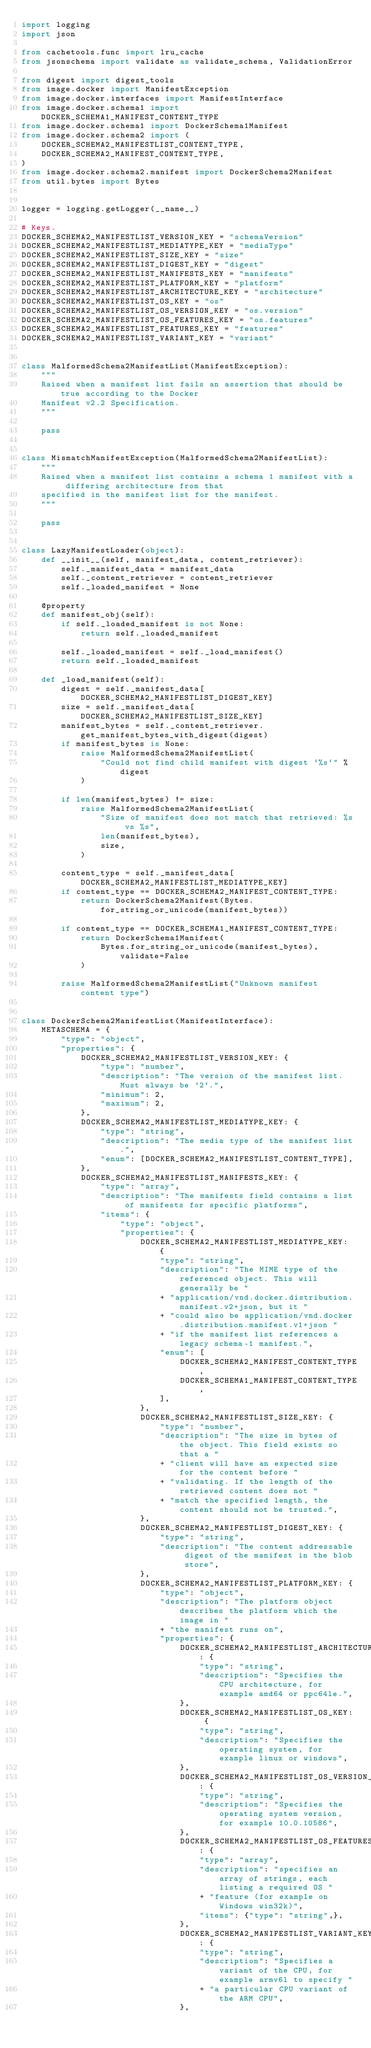Convert code to text. <code><loc_0><loc_0><loc_500><loc_500><_Python_>import logging
import json

from cachetools.func import lru_cache
from jsonschema import validate as validate_schema, ValidationError

from digest import digest_tools
from image.docker import ManifestException
from image.docker.interfaces import ManifestInterface
from image.docker.schema1 import DOCKER_SCHEMA1_MANIFEST_CONTENT_TYPE
from image.docker.schema1 import DockerSchema1Manifest
from image.docker.schema2 import (
    DOCKER_SCHEMA2_MANIFESTLIST_CONTENT_TYPE,
    DOCKER_SCHEMA2_MANIFEST_CONTENT_TYPE,
)
from image.docker.schema2.manifest import DockerSchema2Manifest
from util.bytes import Bytes


logger = logging.getLogger(__name__)

# Keys.
DOCKER_SCHEMA2_MANIFESTLIST_VERSION_KEY = "schemaVersion"
DOCKER_SCHEMA2_MANIFESTLIST_MEDIATYPE_KEY = "mediaType"
DOCKER_SCHEMA2_MANIFESTLIST_SIZE_KEY = "size"
DOCKER_SCHEMA2_MANIFESTLIST_DIGEST_KEY = "digest"
DOCKER_SCHEMA2_MANIFESTLIST_MANIFESTS_KEY = "manifests"
DOCKER_SCHEMA2_MANIFESTLIST_PLATFORM_KEY = "platform"
DOCKER_SCHEMA2_MANIFESTLIST_ARCHITECTURE_KEY = "architecture"
DOCKER_SCHEMA2_MANIFESTLIST_OS_KEY = "os"
DOCKER_SCHEMA2_MANIFESTLIST_OS_VERSION_KEY = "os.version"
DOCKER_SCHEMA2_MANIFESTLIST_OS_FEATURES_KEY = "os.features"
DOCKER_SCHEMA2_MANIFESTLIST_FEATURES_KEY = "features"
DOCKER_SCHEMA2_MANIFESTLIST_VARIANT_KEY = "variant"


class MalformedSchema2ManifestList(ManifestException):
    """
    Raised when a manifest list fails an assertion that should be true according to the Docker
    Manifest v2.2 Specification.
    """

    pass


class MismatchManifestException(MalformedSchema2ManifestList):
    """
    Raised when a manifest list contains a schema 1 manifest with a differing architecture from that
    specified in the manifest list for the manifest.
    """

    pass


class LazyManifestLoader(object):
    def __init__(self, manifest_data, content_retriever):
        self._manifest_data = manifest_data
        self._content_retriever = content_retriever
        self._loaded_manifest = None

    @property
    def manifest_obj(self):
        if self._loaded_manifest is not None:
            return self._loaded_manifest

        self._loaded_manifest = self._load_manifest()
        return self._loaded_manifest

    def _load_manifest(self):
        digest = self._manifest_data[DOCKER_SCHEMA2_MANIFESTLIST_DIGEST_KEY]
        size = self._manifest_data[DOCKER_SCHEMA2_MANIFESTLIST_SIZE_KEY]
        manifest_bytes = self._content_retriever.get_manifest_bytes_with_digest(digest)
        if manifest_bytes is None:
            raise MalformedSchema2ManifestList(
                "Could not find child manifest with digest `%s`" % digest
            )

        if len(manifest_bytes) != size:
            raise MalformedSchema2ManifestList(
                "Size of manifest does not match that retrieved: %s vs %s",
                len(manifest_bytes),
                size,
            )

        content_type = self._manifest_data[DOCKER_SCHEMA2_MANIFESTLIST_MEDIATYPE_KEY]
        if content_type == DOCKER_SCHEMA2_MANIFEST_CONTENT_TYPE:
            return DockerSchema2Manifest(Bytes.for_string_or_unicode(manifest_bytes))

        if content_type == DOCKER_SCHEMA1_MANIFEST_CONTENT_TYPE:
            return DockerSchema1Manifest(
                Bytes.for_string_or_unicode(manifest_bytes), validate=False
            )

        raise MalformedSchema2ManifestList("Unknown manifest content type")


class DockerSchema2ManifestList(ManifestInterface):
    METASCHEMA = {
        "type": "object",
        "properties": {
            DOCKER_SCHEMA2_MANIFESTLIST_VERSION_KEY: {
                "type": "number",
                "description": "The version of the manifest list. Must always be `2`.",
                "minimum": 2,
                "maximum": 2,
            },
            DOCKER_SCHEMA2_MANIFESTLIST_MEDIATYPE_KEY: {
                "type": "string",
                "description": "The media type of the manifest list.",
                "enum": [DOCKER_SCHEMA2_MANIFESTLIST_CONTENT_TYPE],
            },
            DOCKER_SCHEMA2_MANIFESTLIST_MANIFESTS_KEY: {
                "type": "array",
                "description": "The manifests field contains a list of manifests for specific platforms",
                "items": {
                    "type": "object",
                    "properties": {
                        DOCKER_SCHEMA2_MANIFESTLIST_MEDIATYPE_KEY: {
                            "type": "string",
                            "description": "The MIME type of the referenced object. This will generally be "
                            + "application/vnd.docker.distribution.manifest.v2+json, but it "
                            + "could also be application/vnd.docker.distribution.manifest.v1+json "
                            + "if the manifest list references a legacy schema-1 manifest.",
                            "enum": [
                                DOCKER_SCHEMA2_MANIFEST_CONTENT_TYPE,
                                DOCKER_SCHEMA1_MANIFEST_CONTENT_TYPE,
                            ],
                        },
                        DOCKER_SCHEMA2_MANIFESTLIST_SIZE_KEY: {
                            "type": "number",
                            "description": "The size in bytes of the object. This field exists so that a "
                            + "client will have an expected size for the content before "
                            + "validating. If the length of the retrieved content does not "
                            + "match the specified length, the content should not be trusted.",
                        },
                        DOCKER_SCHEMA2_MANIFESTLIST_DIGEST_KEY: {
                            "type": "string",
                            "description": "The content addressable digest of the manifest in the blob store",
                        },
                        DOCKER_SCHEMA2_MANIFESTLIST_PLATFORM_KEY: {
                            "type": "object",
                            "description": "The platform object describes the platform which the image in "
                            + "the manifest runs on",
                            "properties": {
                                DOCKER_SCHEMA2_MANIFESTLIST_ARCHITECTURE_KEY: {
                                    "type": "string",
                                    "description": "Specifies the CPU architecture, for example amd64 or ppc64le.",
                                },
                                DOCKER_SCHEMA2_MANIFESTLIST_OS_KEY: {
                                    "type": "string",
                                    "description": "Specifies the operating system, for example linux or windows",
                                },
                                DOCKER_SCHEMA2_MANIFESTLIST_OS_VERSION_KEY: {
                                    "type": "string",
                                    "description": "Specifies the operating system version, for example 10.0.10586",
                                },
                                DOCKER_SCHEMA2_MANIFESTLIST_OS_FEATURES_KEY: {
                                    "type": "array",
                                    "description": "specifies an array of strings, each listing a required OS "
                                    + "feature (for example on Windows win32k)",
                                    "items": {"type": "string",},
                                },
                                DOCKER_SCHEMA2_MANIFESTLIST_VARIANT_KEY: {
                                    "type": "string",
                                    "description": "Specifies a variant of the CPU, for example armv6l to specify "
                                    + "a particular CPU variant of the ARM CPU",
                                },</code> 